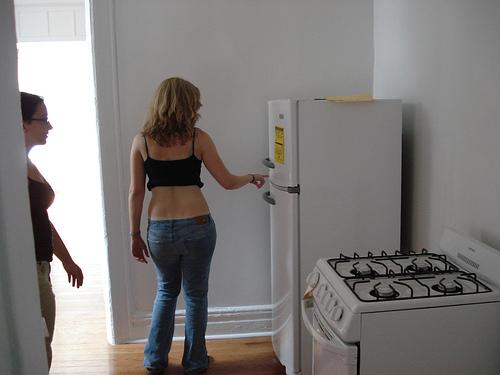What type of outfit is the woman wearing in the kitchen scene? The woman is wearing a black tank top and blue jeans. Mention two things the woman examining the refrigerator is wearing on her arms. The woman has a wristband on her right arm and a wristband on her left arm. What is the color of the wall in the background and what is the woman in blue jeans doing? The wall in the background is white, and the woman in blue jeans is looking at a fridge. Mention two features about the refrigerator. It has a white side and a black and yellow sticker on the front. In the given scene with two women in a kitchen, what is one of the women wearing and what is she doing? One woman is wearing a brown shirt and is opening the refrigerator. What kind of top is the woman wearing and what color is it? The woman is wearing a black tank top or halter top. What is the woman in the picture doing and what does she wear on her upper body? The woman is examining a refrigerator and she is wearing a black tank top. What is the main piece of furniture in the image and its main color? The main piece of furniture is a white stove against the wall. Describe the woman's appearance, including her hair color and what she is wearing. The woman has light brown hair, is wearing glasses, a black tank top, blue jeans, and bracelets on both wrists. What are the two main pieces of kitchen appliances visible in the image? The refrigerator and the oven next to it. 